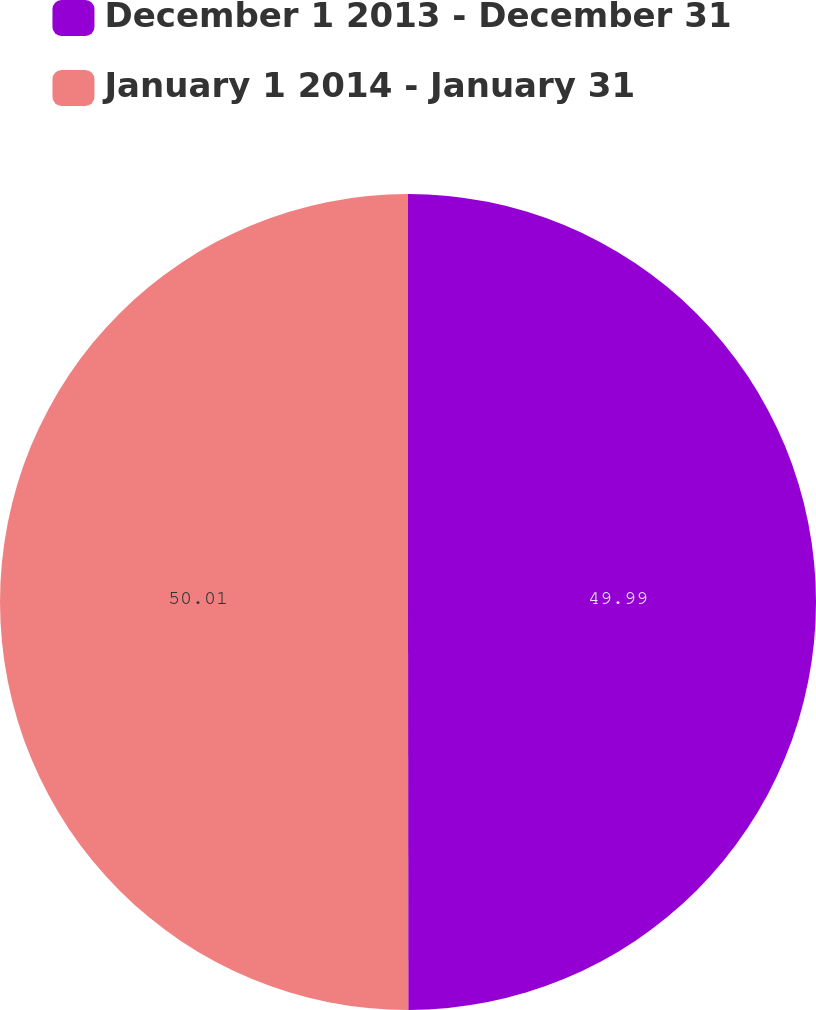<chart> <loc_0><loc_0><loc_500><loc_500><pie_chart><fcel>December 1 2013 - December 31<fcel>January 1 2014 - January 31<nl><fcel>49.99%<fcel>50.01%<nl></chart> 